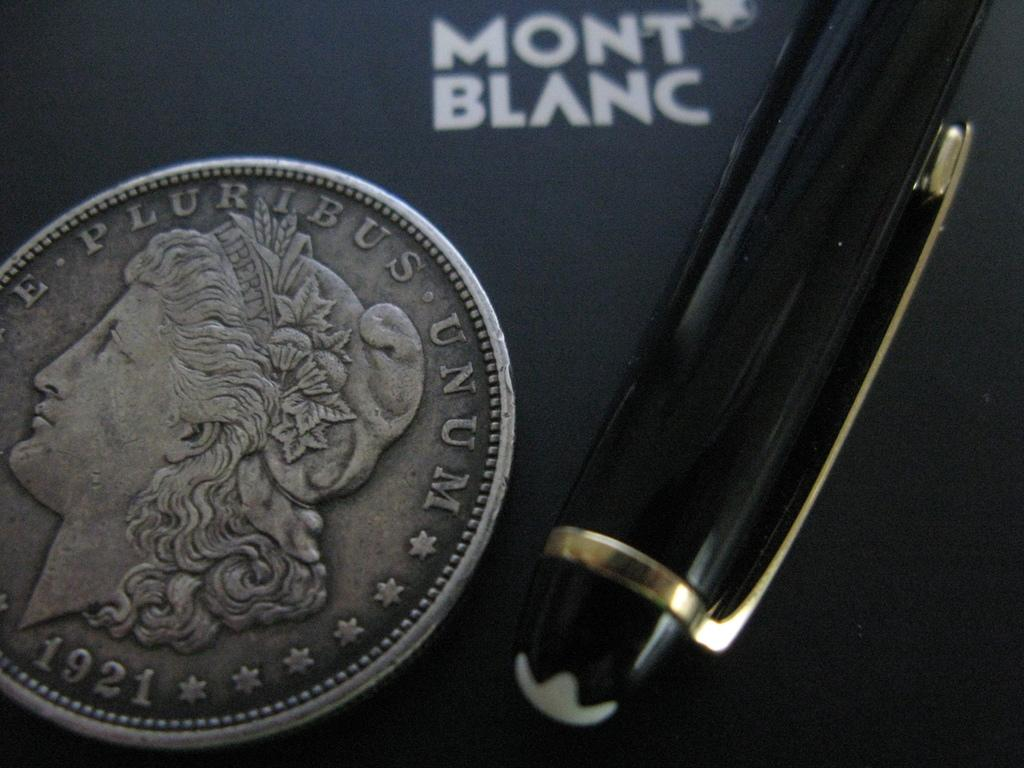Provide a one-sentence caption for the provided image. A 1921 coin and a pen on a paper advertising Mont Blanc. 